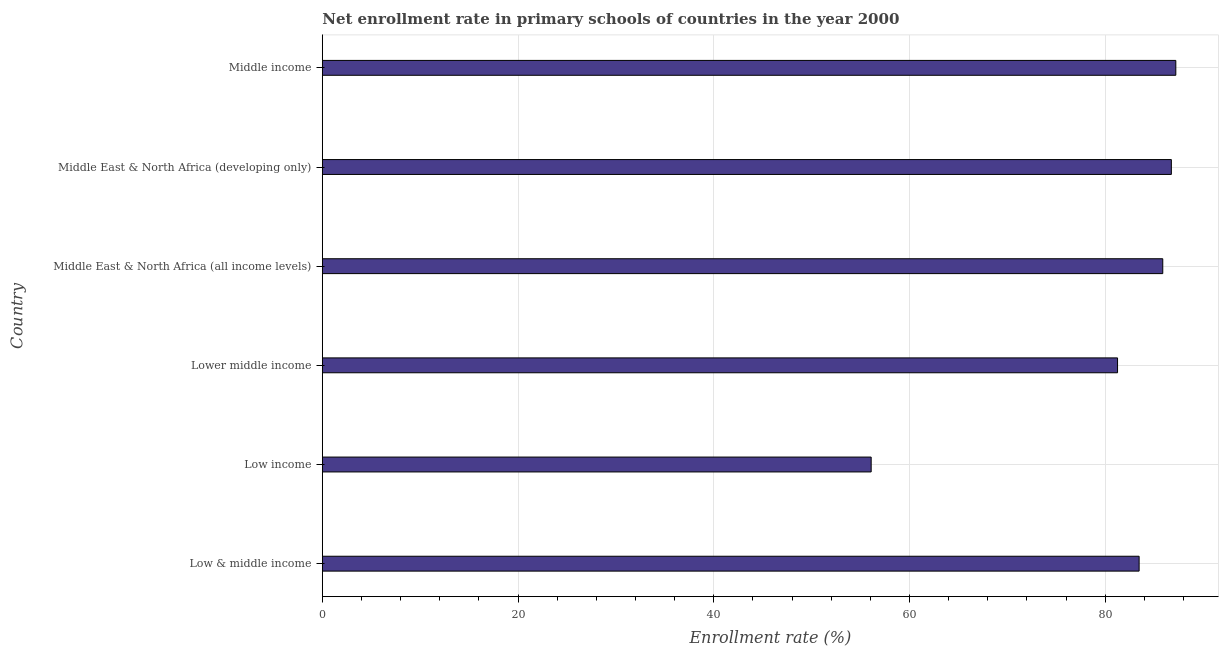Does the graph contain any zero values?
Offer a very short reply. No. Does the graph contain grids?
Your answer should be compact. Yes. What is the title of the graph?
Keep it short and to the point. Net enrollment rate in primary schools of countries in the year 2000. What is the label or title of the X-axis?
Provide a short and direct response. Enrollment rate (%). What is the net enrollment rate in primary schools in Middle East & North Africa (developing only)?
Give a very brief answer. 86.76. Across all countries, what is the maximum net enrollment rate in primary schools?
Ensure brevity in your answer.  87.21. Across all countries, what is the minimum net enrollment rate in primary schools?
Offer a very short reply. 56.08. What is the sum of the net enrollment rate in primary schools?
Provide a succinct answer. 480.65. What is the difference between the net enrollment rate in primary schools in Low income and Middle East & North Africa (developing only)?
Keep it short and to the point. -30.67. What is the average net enrollment rate in primary schools per country?
Offer a very short reply. 80.11. What is the median net enrollment rate in primary schools?
Your response must be concise. 84.67. In how many countries, is the net enrollment rate in primary schools greater than 40 %?
Your answer should be very brief. 6. What is the ratio of the net enrollment rate in primary schools in Low & middle income to that in Lower middle income?
Provide a short and direct response. 1.03. Is the difference between the net enrollment rate in primary schools in Low income and Middle East & North Africa (developing only) greater than the difference between any two countries?
Your response must be concise. No. What is the difference between the highest and the second highest net enrollment rate in primary schools?
Ensure brevity in your answer.  0.46. What is the difference between the highest and the lowest net enrollment rate in primary schools?
Your answer should be very brief. 31.13. How many bars are there?
Provide a succinct answer. 6. Are all the bars in the graph horizontal?
Ensure brevity in your answer.  Yes. What is the Enrollment rate (%) in Low & middle income?
Your answer should be compact. 83.46. What is the Enrollment rate (%) in Low income?
Offer a very short reply. 56.08. What is the Enrollment rate (%) of Lower middle income?
Your response must be concise. 81.26. What is the Enrollment rate (%) of Middle East & North Africa (all income levels)?
Offer a very short reply. 85.88. What is the Enrollment rate (%) in Middle East & North Africa (developing only)?
Your answer should be very brief. 86.76. What is the Enrollment rate (%) in Middle income?
Your answer should be very brief. 87.21. What is the difference between the Enrollment rate (%) in Low & middle income and Low income?
Provide a succinct answer. 27.38. What is the difference between the Enrollment rate (%) in Low & middle income and Lower middle income?
Provide a succinct answer. 2.21. What is the difference between the Enrollment rate (%) in Low & middle income and Middle East & North Africa (all income levels)?
Give a very brief answer. -2.42. What is the difference between the Enrollment rate (%) in Low & middle income and Middle East & North Africa (developing only)?
Your response must be concise. -3.29. What is the difference between the Enrollment rate (%) in Low & middle income and Middle income?
Offer a very short reply. -3.75. What is the difference between the Enrollment rate (%) in Low income and Lower middle income?
Make the answer very short. -25.17. What is the difference between the Enrollment rate (%) in Low income and Middle East & North Africa (all income levels)?
Your answer should be compact. -29.8. What is the difference between the Enrollment rate (%) in Low income and Middle East & North Africa (developing only)?
Your response must be concise. -30.67. What is the difference between the Enrollment rate (%) in Low income and Middle income?
Your answer should be very brief. -31.13. What is the difference between the Enrollment rate (%) in Lower middle income and Middle East & North Africa (all income levels)?
Make the answer very short. -4.62. What is the difference between the Enrollment rate (%) in Lower middle income and Middle East & North Africa (developing only)?
Keep it short and to the point. -5.5. What is the difference between the Enrollment rate (%) in Lower middle income and Middle income?
Offer a terse response. -5.95. What is the difference between the Enrollment rate (%) in Middle East & North Africa (all income levels) and Middle East & North Africa (developing only)?
Your answer should be compact. -0.88. What is the difference between the Enrollment rate (%) in Middle East & North Africa (all income levels) and Middle income?
Ensure brevity in your answer.  -1.33. What is the difference between the Enrollment rate (%) in Middle East & North Africa (developing only) and Middle income?
Ensure brevity in your answer.  -0.46. What is the ratio of the Enrollment rate (%) in Low & middle income to that in Low income?
Your answer should be compact. 1.49. What is the ratio of the Enrollment rate (%) in Low & middle income to that in Lower middle income?
Ensure brevity in your answer.  1.03. What is the ratio of the Enrollment rate (%) in Low & middle income to that in Middle East & North Africa (all income levels)?
Keep it short and to the point. 0.97. What is the ratio of the Enrollment rate (%) in Low & middle income to that in Middle income?
Your answer should be compact. 0.96. What is the ratio of the Enrollment rate (%) in Low income to that in Lower middle income?
Give a very brief answer. 0.69. What is the ratio of the Enrollment rate (%) in Low income to that in Middle East & North Africa (all income levels)?
Your answer should be very brief. 0.65. What is the ratio of the Enrollment rate (%) in Low income to that in Middle East & North Africa (developing only)?
Offer a terse response. 0.65. What is the ratio of the Enrollment rate (%) in Low income to that in Middle income?
Your answer should be very brief. 0.64. What is the ratio of the Enrollment rate (%) in Lower middle income to that in Middle East & North Africa (all income levels)?
Your answer should be compact. 0.95. What is the ratio of the Enrollment rate (%) in Lower middle income to that in Middle East & North Africa (developing only)?
Give a very brief answer. 0.94. What is the ratio of the Enrollment rate (%) in Lower middle income to that in Middle income?
Keep it short and to the point. 0.93. What is the ratio of the Enrollment rate (%) in Middle East & North Africa (all income levels) to that in Middle East & North Africa (developing only)?
Your answer should be compact. 0.99. 